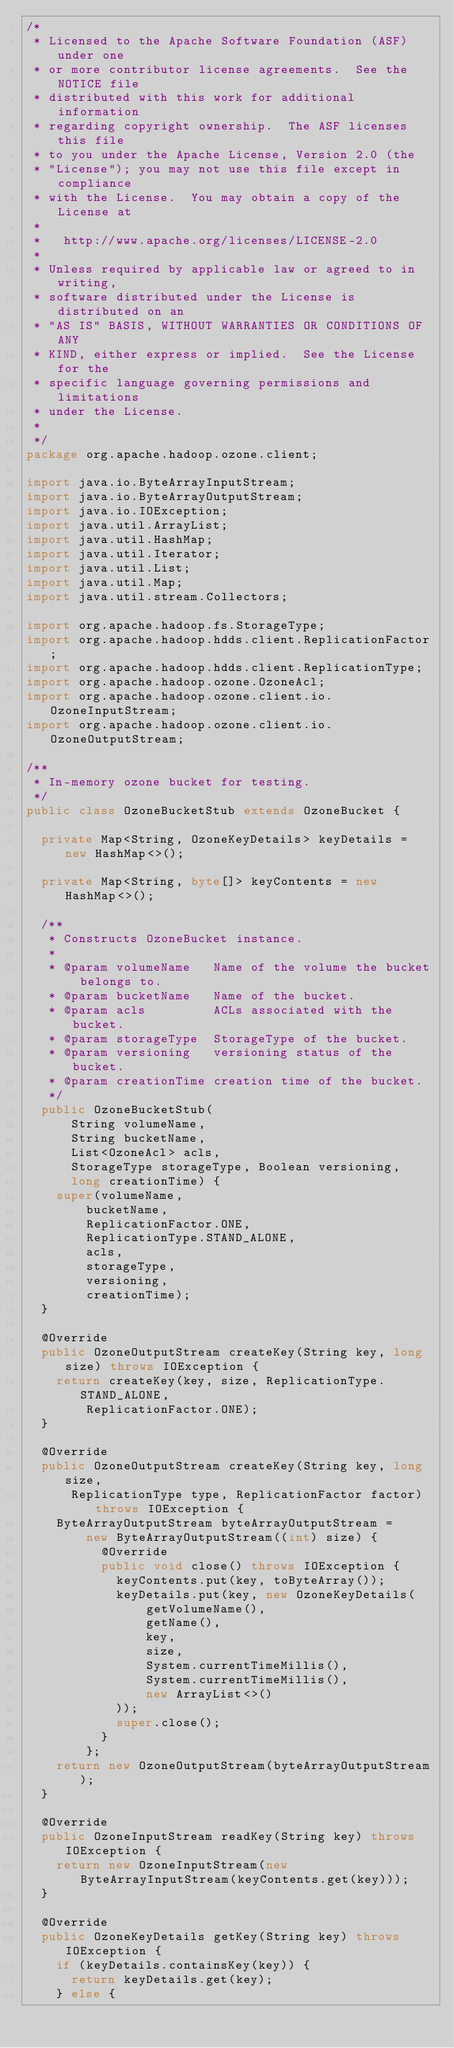Convert code to text. <code><loc_0><loc_0><loc_500><loc_500><_Java_>/*
 * Licensed to the Apache Software Foundation (ASF) under one
 * or more contributor license agreements.  See the NOTICE file
 * distributed with this work for additional information
 * regarding copyright ownership.  The ASF licenses this file
 * to you under the Apache License, Version 2.0 (the
 * "License"); you may not use this file except in compliance
 * with the License.  You may obtain a copy of the License at
 *
 *   http://www.apache.org/licenses/LICENSE-2.0
 *
 * Unless required by applicable law or agreed to in writing,
 * software distributed under the License is distributed on an
 * "AS IS" BASIS, WITHOUT WARRANTIES OR CONDITIONS OF ANY
 * KIND, either express or implied.  See the License for the
 * specific language governing permissions and limitations
 * under the License.
 *
 */
package org.apache.hadoop.ozone.client;

import java.io.ByteArrayInputStream;
import java.io.ByteArrayOutputStream;
import java.io.IOException;
import java.util.ArrayList;
import java.util.HashMap;
import java.util.Iterator;
import java.util.List;
import java.util.Map;
import java.util.stream.Collectors;

import org.apache.hadoop.fs.StorageType;
import org.apache.hadoop.hdds.client.ReplicationFactor;
import org.apache.hadoop.hdds.client.ReplicationType;
import org.apache.hadoop.ozone.OzoneAcl;
import org.apache.hadoop.ozone.client.io.OzoneInputStream;
import org.apache.hadoop.ozone.client.io.OzoneOutputStream;

/**
 * In-memory ozone bucket for testing.
 */
public class OzoneBucketStub extends OzoneBucket {

  private Map<String, OzoneKeyDetails> keyDetails = new HashMap<>();

  private Map<String, byte[]> keyContents = new HashMap<>();

  /**
   * Constructs OzoneBucket instance.
   *
   * @param volumeName   Name of the volume the bucket belongs to.
   * @param bucketName   Name of the bucket.
   * @param acls         ACLs associated with the bucket.
   * @param storageType  StorageType of the bucket.
   * @param versioning   versioning status of the bucket.
   * @param creationTime creation time of the bucket.
   */
  public OzoneBucketStub(
      String volumeName,
      String bucketName,
      List<OzoneAcl> acls,
      StorageType storageType, Boolean versioning,
      long creationTime) {
    super(volumeName,
        bucketName,
        ReplicationFactor.ONE,
        ReplicationType.STAND_ALONE,
        acls,
        storageType,
        versioning,
        creationTime);
  }

  @Override
  public OzoneOutputStream createKey(String key, long size) throws IOException {
    return createKey(key, size, ReplicationType.STAND_ALONE,
        ReplicationFactor.ONE);
  }

  @Override
  public OzoneOutputStream createKey(String key, long size,
      ReplicationType type, ReplicationFactor factor) throws IOException {
    ByteArrayOutputStream byteArrayOutputStream =
        new ByteArrayOutputStream((int) size) {
          @Override
          public void close() throws IOException {
            keyContents.put(key, toByteArray());
            keyDetails.put(key, new OzoneKeyDetails(
                getVolumeName(),
                getName(),
                key,
                size,
                System.currentTimeMillis(),
                System.currentTimeMillis(),
                new ArrayList<>()
            ));
            super.close();
          }
        };
    return new OzoneOutputStream(byteArrayOutputStream);
  }

  @Override
  public OzoneInputStream readKey(String key) throws IOException {
    return new OzoneInputStream(new ByteArrayInputStream(keyContents.get(key)));
  }

  @Override
  public OzoneKeyDetails getKey(String key) throws IOException {
    if (keyDetails.containsKey(key)) {
      return keyDetails.get(key);
    } else {</code> 